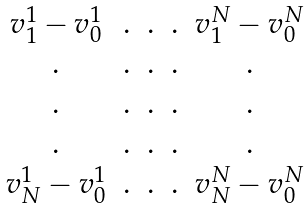Convert formula to latex. <formula><loc_0><loc_0><loc_500><loc_500>\begin{matrix} v ^ { 1 } _ { 1 } - v ^ { 1 } _ { 0 } & . & . & . & v ^ { N } _ { 1 } - v ^ { N } _ { 0 } \\ . & . & . & . & . \\ . & . & . & . & . \\ . & . & . & . & . \\ v ^ { 1 } _ { N } - v ^ { 1 } _ { 0 } & . & . & . & v ^ { N } _ { N } - v ^ { N } _ { 0 } \end{matrix}</formula> 